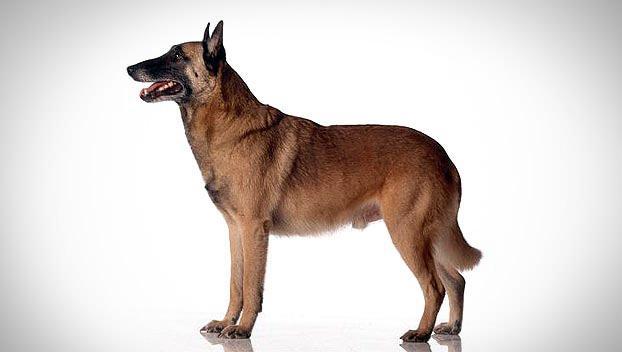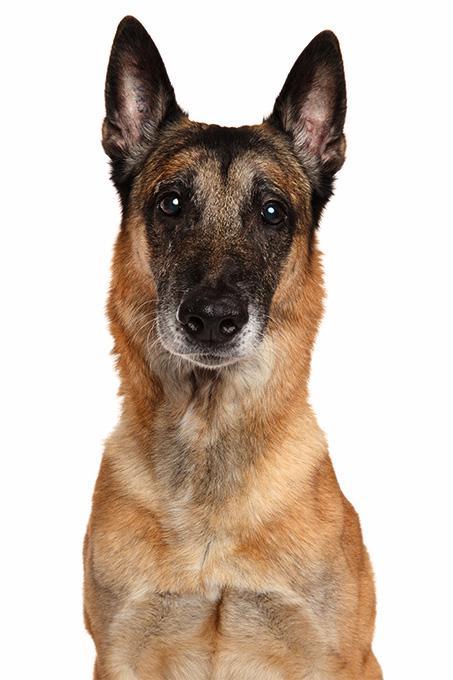The first image is the image on the left, the second image is the image on the right. For the images displayed, is the sentence "An image shows a german shepherd wearing a collar." factually correct? Answer yes or no. No. 